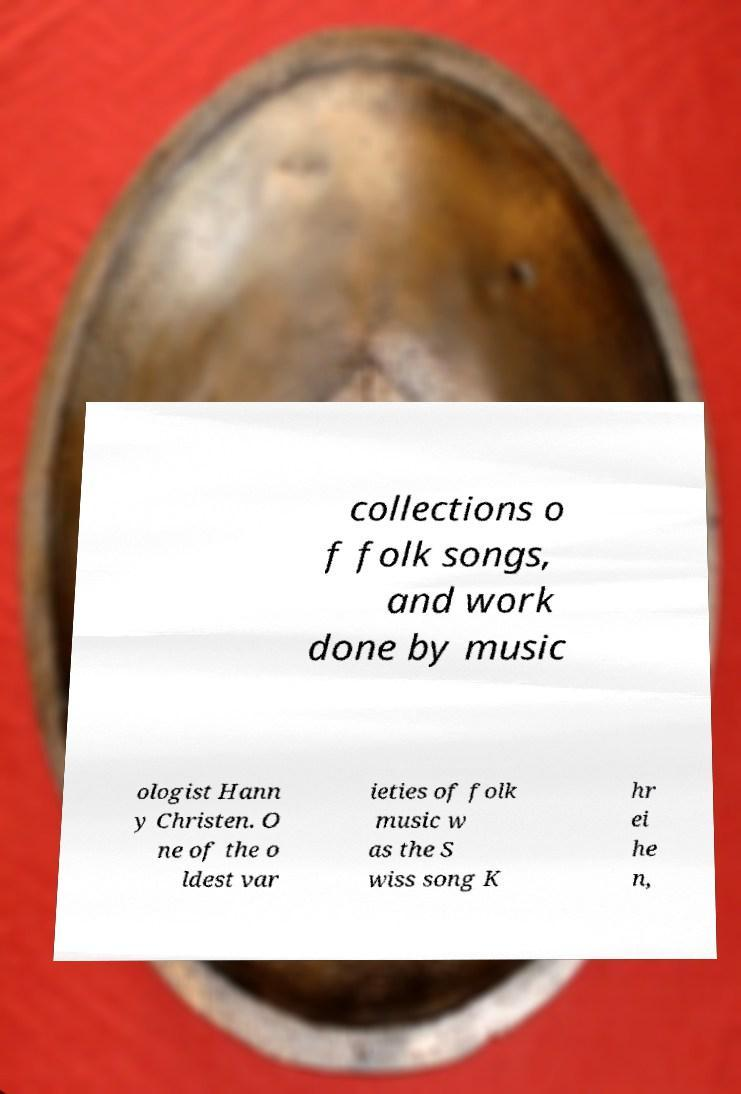There's text embedded in this image that I need extracted. Can you transcribe it verbatim? collections o f folk songs, and work done by music ologist Hann y Christen. O ne of the o ldest var ieties of folk music w as the S wiss song K hr ei he n, 